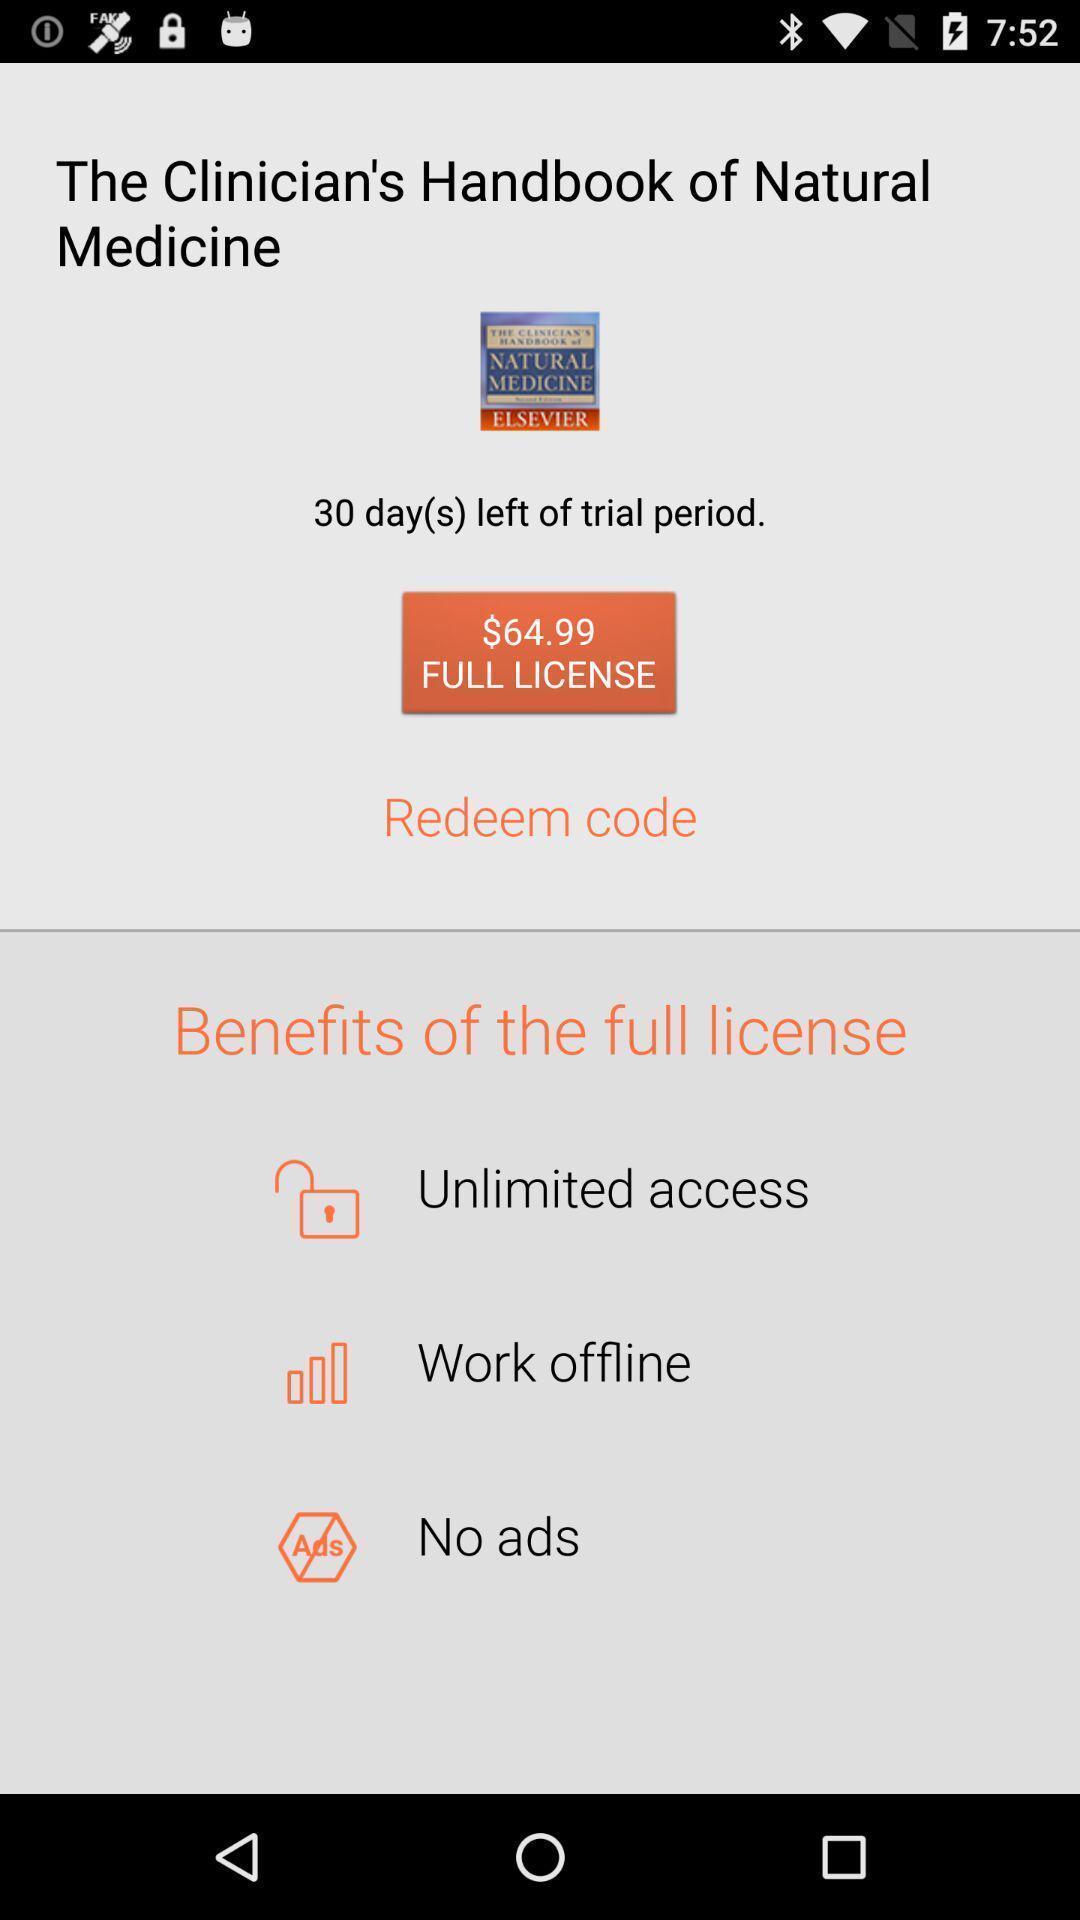Give me a summary of this screen capture. Page displaying image of a medicine app. 